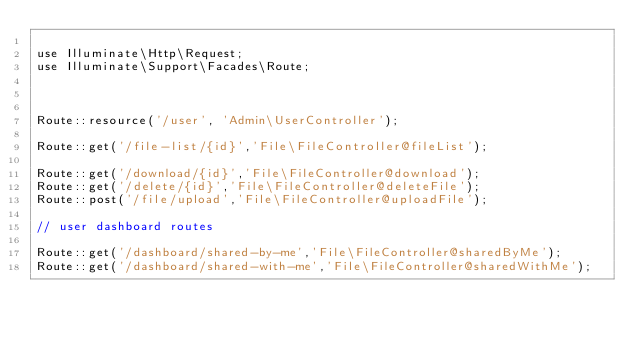Convert code to text. <code><loc_0><loc_0><loc_500><loc_500><_PHP_>
use Illuminate\Http\Request;
use Illuminate\Support\Facades\Route;



Route::resource('/user', 'Admin\UserController');

Route::get('/file-list/{id}','File\FileController@fileList');

Route::get('/download/{id}','File\FileController@download');
Route::get('/delete/{id}','File\FileController@deleteFile');
Route::post('/file/upload','File\FileController@uploadFile');

// user dashboard routes

Route::get('/dashboard/shared-by-me','File\FileController@sharedByMe');
Route::get('/dashboard/shared-with-me','File\FileController@sharedWithMe');</code> 